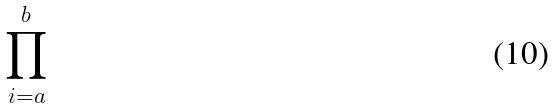<formula> <loc_0><loc_0><loc_500><loc_500>\prod _ { i = a } ^ { b }</formula> 